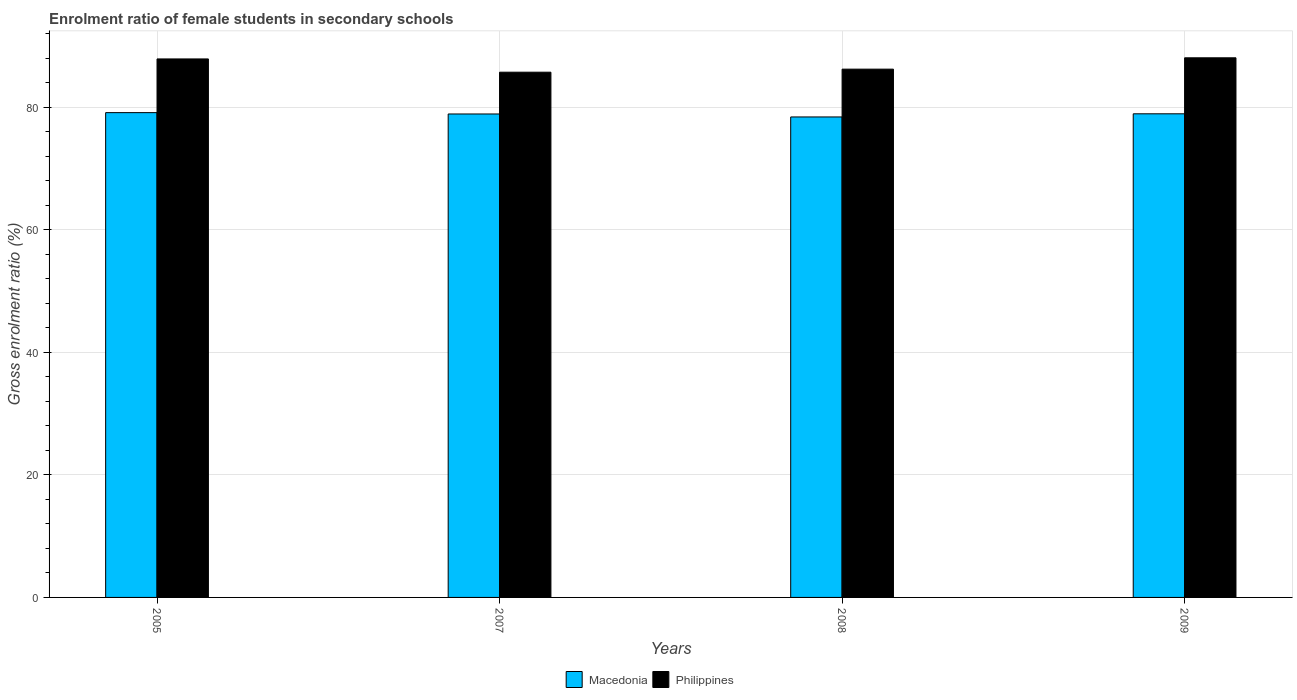How many different coloured bars are there?
Make the answer very short. 2. How many groups of bars are there?
Your answer should be compact. 4. Are the number of bars on each tick of the X-axis equal?
Keep it short and to the point. Yes. How many bars are there on the 2nd tick from the left?
Your response must be concise. 2. In how many cases, is the number of bars for a given year not equal to the number of legend labels?
Provide a succinct answer. 0. What is the enrolment ratio of female students in secondary schools in Macedonia in 2005?
Ensure brevity in your answer.  79.09. Across all years, what is the maximum enrolment ratio of female students in secondary schools in Macedonia?
Ensure brevity in your answer.  79.09. Across all years, what is the minimum enrolment ratio of female students in secondary schools in Macedonia?
Your answer should be compact. 78.38. What is the total enrolment ratio of female students in secondary schools in Macedonia in the graph?
Provide a succinct answer. 315.24. What is the difference between the enrolment ratio of female students in secondary schools in Philippines in 2007 and that in 2009?
Make the answer very short. -2.35. What is the difference between the enrolment ratio of female students in secondary schools in Macedonia in 2007 and the enrolment ratio of female students in secondary schools in Philippines in 2005?
Your answer should be very brief. -8.98. What is the average enrolment ratio of female students in secondary schools in Macedonia per year?
Keep it short and to the point. 78.81. In the year 2007, what is the difference between the enrolment ratio of female students in secondary schools in Philippines and enrolment ratio of female students in secondary schools in Macedonia?
Ensure brevity in your answer.  6.82. What is the ratio of the enrolment ratio of female students in secondary schools in Macedonia in 2005 to that in 2008?
Offer a terse response. 1.01. Is the difference between the enrolment ratio of female students in secondary schools in Philippines in 2007 and 2009 greater than the difference between the enrolment ratio of female students in secondary schools in Macedonia in 2007 and 2009?
Offer a terse response. No. What is the difference between the highest and the second highest enrolment ratio of female students in secondary schools in Macedonia?
Provide a short and direct response. 0.19. What is the difference between the highest and the lowest enrolment ratio of female students in secondary schools in Philippines?
Keep it short and to the point. 2.35. In how many years, is the enrolment ratio of female students in secondary schools in Macedonia greater than the average enrolment ratio of female students in secondary schools in Macedonia taken over all years?
Offer a terse response. 3. What does the 2nd bar from the left in 2005 represents?
Make the answer very short. Philippines. What does the 2nd bar from the right in 2007 represents?
Make the answer very short. Macedonia. How many bars are there?
Offer a terse response. 8. How many years are there in the graph?
Offer a terse response. 4. What is the difference between two consecutive major ticks on the Y-axis?
Keep it short and to the point. 20. Are the values on the major ticks of Y-axis written in scientific E-notation?
Your answer should be very brief. No. Does the graph contain any zero values?
Your answer should be very brief. No. Does the graph contain grids?
Offer a very short reply. Yes. What is the title of the graph?
Make the answer very short. Enrolment ratio of female students in secondary schools. Does "Saudi Arabia" appear as one of the legend labels in the graph?
Give a very brief answer. No. What is the Gross enrolment ratio (%) of Macedonia in 2005?
Ensure brevity in your answer.  79.09. What is the Gross enrolment ratio (%) in Philippines in 2005?
Keep it short and to the point. 87.85. What is the Gross enrolment ratio (%) in Macedonia in 2007?
Your response must be concise. 78.87. What is the Gross enrolment ratio (%) of Philippines in 2007?
Make the answer very short. 85.69. What is the Gross enrolment ratio (%) of Macedonia in 2008?
Give a very brief answer. 78.38. What is the Gross enrolment ratio (%) of Philippines in 2008?
Your answer should be very brief. 86.18. What is the Gross enrolment ratio (%) in Macedonia in 2009?
Keep it short and to the point. 78.9. What is the Gross enrolment ratio (%) in Philippines in 2009?
Keep it short and to the point. 88.03. Across all years, what is the maximum Gross enrolment ratio (%) of Macedonia?
Provide a short and direct response. 79.09. Across all years, what is the maximum Gross enrolment ratio (%) of Philippines?
Give a very brief answer. 88.03. Across all years, what is the minimum Gross enrolment ratio (%) of Macedonia?
Provide a succinct answer. 78.38. Across all years, what is the minimum Gross enrolment ratio (%) of Philippines?
Your response must be concise. 85.69. What is the total Gross enrolment ratio (%) in Macedonia in the graph?
Give a very brief answer. 315.24. What is the total Gross enrolment ratio (%) in Philippines in the graph?
Provide a succinct answer. 347.75. What is the difference between the Gross enrolment ratio (%) in Macedonia in 2005 and that in 2007?
Give a very brief answer. 0.22. What is the difference between the Gross enrolment ratio (%) of Philippines in 2005 and that in 2007?
Ensure brevity in your answer.  2.16. What is the difference between the Gross enrolment ratio (%) in Macedonia in 2005 and that in 2008?
Provide a succinct answer. 0.7. What is the difference between the Gross enrolment ratio (%) of Philippines in 2005 and that in 2008?
Offer a terse response. 1.67. What is the difference between the Gross enrolment ratio (%) of Macedonia in 2005 and that in 2009?
Offer a terse response. 0.19. What is the difference between the Gross enrolment ratio (%) of Philippines in 2005 and that in 2009?
Keep it short and to the point. -0.18. What is the difference between the Gross enrolment ratio (%) of Macedonia in 2007 and that in 2008?
Your response must be concise. 0.48. What is the difference between the Gross enrolment ratio (%) in Philippines in 2007 and that in 2008?
Provide a short and direct response. -0.5. What is the difference between the Gross enrolment ratio (%) in Macedonia in 2007 and that in 2009?
Ensure brevity in your answer.  -0.03. What is the difference between the Gross enrolment ratio (%) in Philippines in 2007 and that in 2009?
Offer a terse response. -2.35. What is the difference between the Gross enrolment ratio (%) of Macedonia in 2008 and that in 2009?
Make the answer very short. -0.51. What is the difference between the Gross enrolment ratio (%) in Philippines in 2008 and that in 2009?
Provide a succinct answer. -1.85. What is the difference between the Gross enrolment ratio (%) in Macedonia in 2005 and the Gross enrolment ratio (%) in Philippines in 2007?
Provide a short and direct response. -6.6. What is the difference between the Gross enrolment ratio (%) in Macedonia in 2005 and the Gross enrolment ratio (%) in Philippines in 2008?
Offer a very short reply. -7.09. What is the difference between the Gross enrolment ratio (%) in Macedonia in 2005 and the Gross enrolment ratio (%) in Philippines in 2009?
Offer a very short reply. -8.94. What is the difference between the Gross enrolment ratio (%) of Macedonia in 2007 and the Gross enrolment ratio (%) of Philippines in 2008?
Your answer should be very brief. -7.31. What is the difference between the Gross enrolment ratio (%) of Macedonia in 2007 and the Gross enrolment ratio (%) of Philippines in 2009?
Your answer should be compact. -9.16. What is the difference between the Gross enrolment ratio (%) of Macedonia in 2008 and the Gross enrolment ratio (%) of Philippines in 2009?
Ensure brevity in your answer.  -9.65. What is the average Gross enrolment ratio (%) of Macedonia per year?
Provide a succinct answer. 78.81. What is the average Gross enrolment ratio (%) of Philippines per year?
Keep it short and to the point. 86.94. In the year 2005, what is the difference between the Gross enrolment ratio (%) in Macedonia and Gross enrolment ratio (%) in Philippines?
Keep it short and to the point. -8.76. In the year 2007, what is the difference between the Gross enrolment ratio (%) of Macedonia and Gross enrolment ratio (%) of Philippines?
Offer a terse response. -6.82. In the year 2008, what is the difference between the Gross enrolment ratio (%) in Macedonia and Gross enrolment ratio (%) in Philippines?
Keep it short and to the point. -7.8. In the year 2009, what is the difference between the Gross enrolment ratio (%) in Macedonia and Gross enrolment ratio (%) in Philippines?
Your response must be concise. -9.14. What is the ratio of the Gross enrolment ratio (%) of Macedonia in 2005 to that in 2007?
Provide a succinct answer. 1. What is the ratio of the Gross enrolment ratio (%) of Philippines in 2005 to that in 2007?
Ensure brevity in your answer.  1.03. What is the ratio of the Gross enrolment ratio (%) of Macedonia in 2005 to that in 2008?
Your response must be concise. 1.01. What is the ratio of the Gross enrolment ratio (%) in Philippines in 2005 to that in 2008?
Give a very brief answer. 1.02. What is the ratio of the Gross enrolment ratio (%) of Macedonia in 2005 to that in 2009?
Give a very brief answer. 1. What is the ratio of the Gross enrolment ratio (%) in Macedonia in 2007 to that in 2008?
Keep it short and to the point. 1.01. What is the ratio of the Gross enrolment ratio (%) of Macedonia in 2007 to that in 2009?
Keep it short and to the point. 1. What is the ratio of the Gross enrolment ratio (%) of Philippines in 2007 to that in 2009?
Provide a short and direct response. 0.97. What is the ratio of the Gross enrolment ratio (%) in Macedonia in 2008 to that in 2009?
Your answer should be compact. 0.99. What is the ratio of the Gross enrolment ratio (%) of Philippines in 2008 to that in 2009?
Provide a succinct answer. 0.98. What is the difference between the highest and the second highest Gross enrolment ratio (%) in Macedonia?
Provide a short and direct response. 0.19. What is the difference between the highest and the second highest Gross enrolment ratio (%) in Philippines?
Provide a short and direct response. 0.18. What is the difference between the highest and the lowest Gross enrolment ratio (%) of Macedonia?
Give a very brief answer. 0.7. What is the difference between the highest and the lowest Gross enrolment ratio (%) in Philippines?
Ensure brevity in your answer.  2.35. 